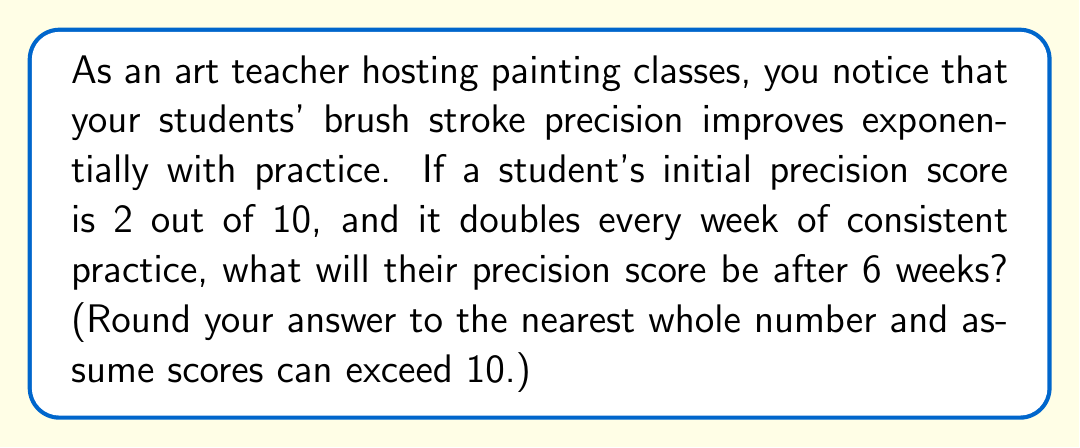Show me your answer to this math problem. Let's approach this step-by-step:

1) The initial precision score is 2.

2) The score doubles every week, which means it's multiplied by 2 each time.

3) This can be represented as an exponential function:
   $$ f(x) = 2 \cdot 2^x $$
   where $x$ is the number of weeks and 2 is the initial score.

4) We want to find the score after 6 weeks, so we'll calculate $f(6)$:
   $$ f(6) = 2 \cdot 2^6 $$

5) Let's solve this:
   $$ f(6) = 2 \cdot 2^6 = 2 \cdot 64 = 128 $$

6) Rounding 128 to the nearest whole number:
   $$ 128 \approx 128 $$

Therefore, after 6 weeks of practice, the student's precision score will be approximately 128 out of 10 (assuming scores can exceed 10).
Answer: 128 